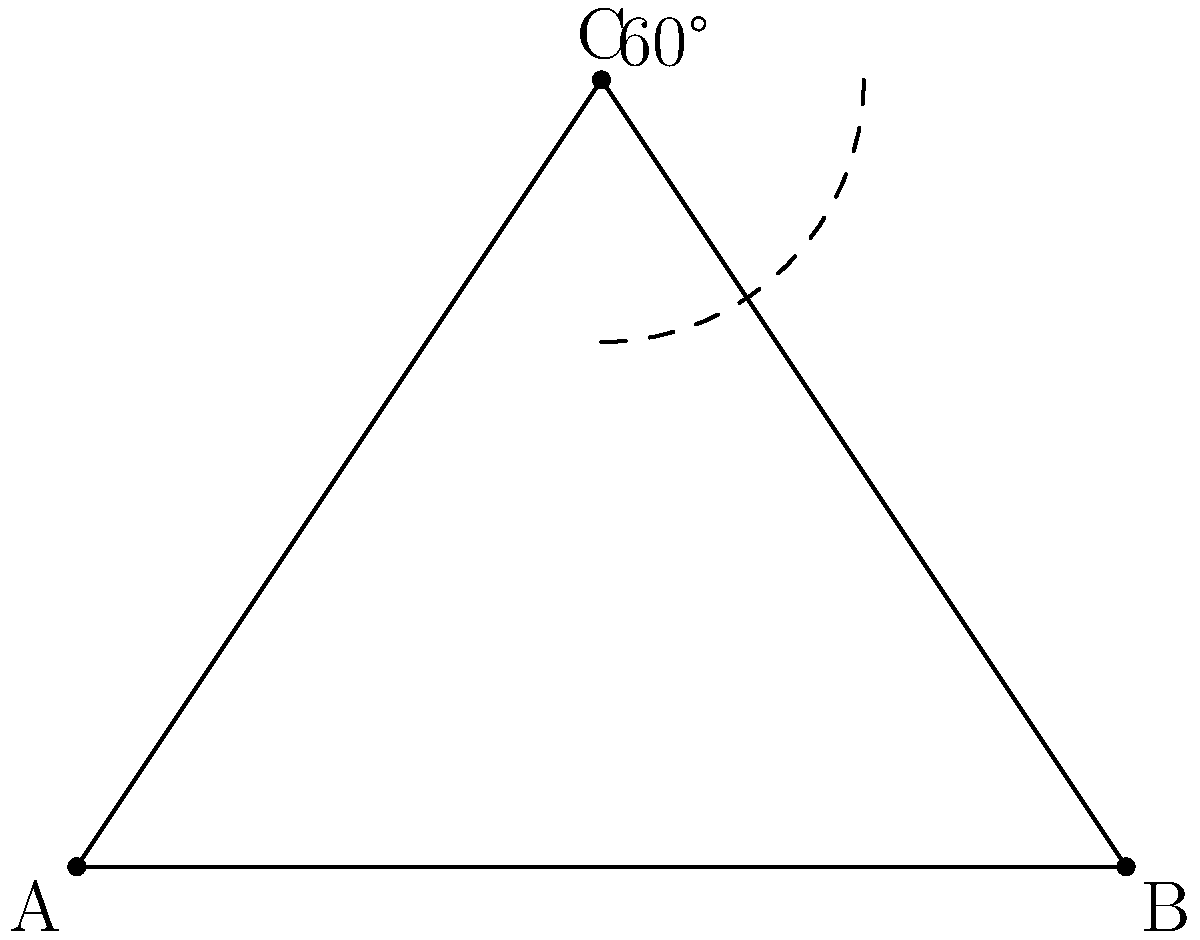In the architectural design of a Gothic cathedral's rose window, a triangular section forms part of the intricate pattern. Given that the triangle ABC represents this section, with angle C measuring 60°, calculate the measure of angle A. To solve this problem, we'll use the properties of triangles:

1) First, recall that the sum of angles in any triangle is always 180°.

2) We're given that angle C is 60°.

3) The triangle appears to be isosceles, with AC = BC. In an isosceles triangle, the angles opposite the equal sides are equal. Therefore, angle A = angle B.

4) Let's call the measure of angle A (and B) $x$.

5) We can now set up an equation based on the fact that the sum of angles in a triangle is 180°:

   $x + x + 60° = 180°$

6) Simplify:
   $2x + 60° = 180°$

7) Subtract 60° from both sides:
   $2x = 120°$

8) Divide both sides by 2:
   $x = 60°$

Therefore, angle A measures 60°.
Answer: 60° 